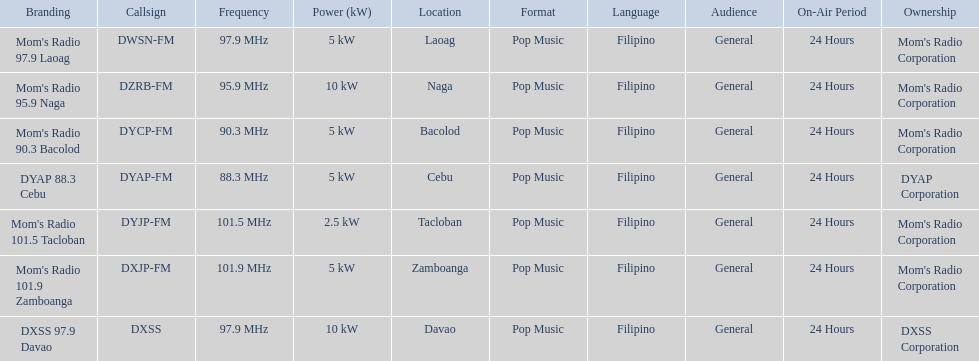What brandings have a power of 5 kw? Mom's Radio 97.9 Laoag, Mom's Radio 90.3 Bacolod, DYAP 88.3 Cebu, Mom's Radio 101.9 Zamboanga. Which of these has a call-sign beginning with dy? Mom's Radio 90.3 Bacolod, DYAP 88.3 Cebu. Which of those uses the lowest frequency? DYAP 88.3 Cebu. 